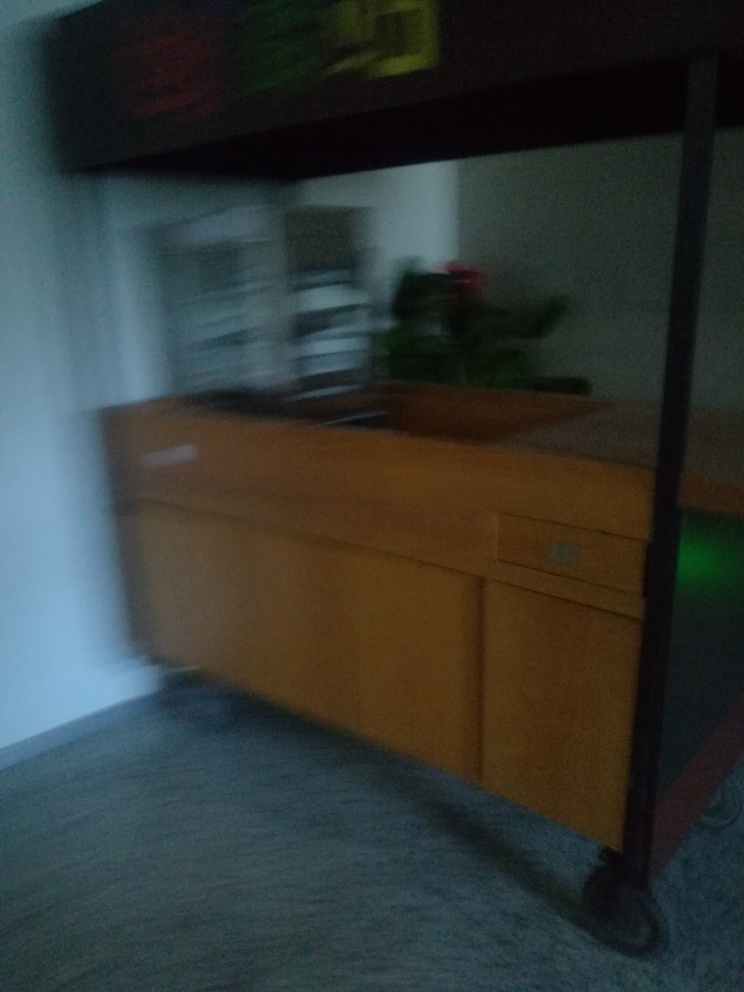Can you describe what might have led to the creation of this blurred effect? The blurred effect in the image could have originated from camera movement during the exposure. The photographer might have moved the camera unintentionally, or this could have been a deliberate attempt to capture a sense of motion. 